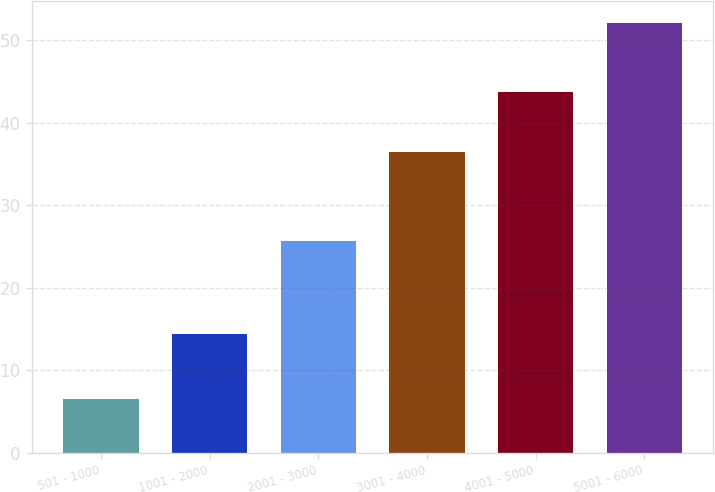Convert chart to OTSL. <chart><loc_0><loc_0><loc_500><loc_500><bar_chart><fcel>501 - 1000<fcel>1001 - 2000<fcel>2001 - 3000<fcel>3001 - 4000<fcel>4001 - 5000<fcel>5001 - 6000<nl><fcel>6.5<fcel>14.39<fcel>25.68<fcel>36.47<fcel>43.69<fcel>52.12<nl></chart> 